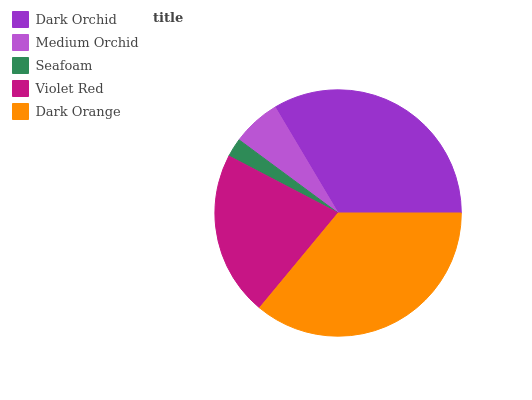Is Seafoam the minimum?
Answer yes or no. Yes. Is Dark Orange the maximum?
Answer yes or no. Yes. Is Medium Orchid the minimum?
Answer yes or no. No. Is Medium Orchid the maximum?
Answer yes or no. No. Is Dark Orchid greater than Medium Orchid?
Answer yes or no. Yes. Is Medium Orchid less than Dark Orchid?
Answer yes or no. Yes. Is Medium Orchid greater than Dark Orchid?
Answer yes or no. No. Is Dark Orchid less than Medium Orchid?
Answer yes or no. No. Is Violet Red the high median?
Answer yes or no. Yes. Is Violet Red the low median?
Answer yes or no. Yes. Is Dark Orange the high median?
Answer yes or no. No. Is Seafoam the low median?
Answer yes or no. No. 